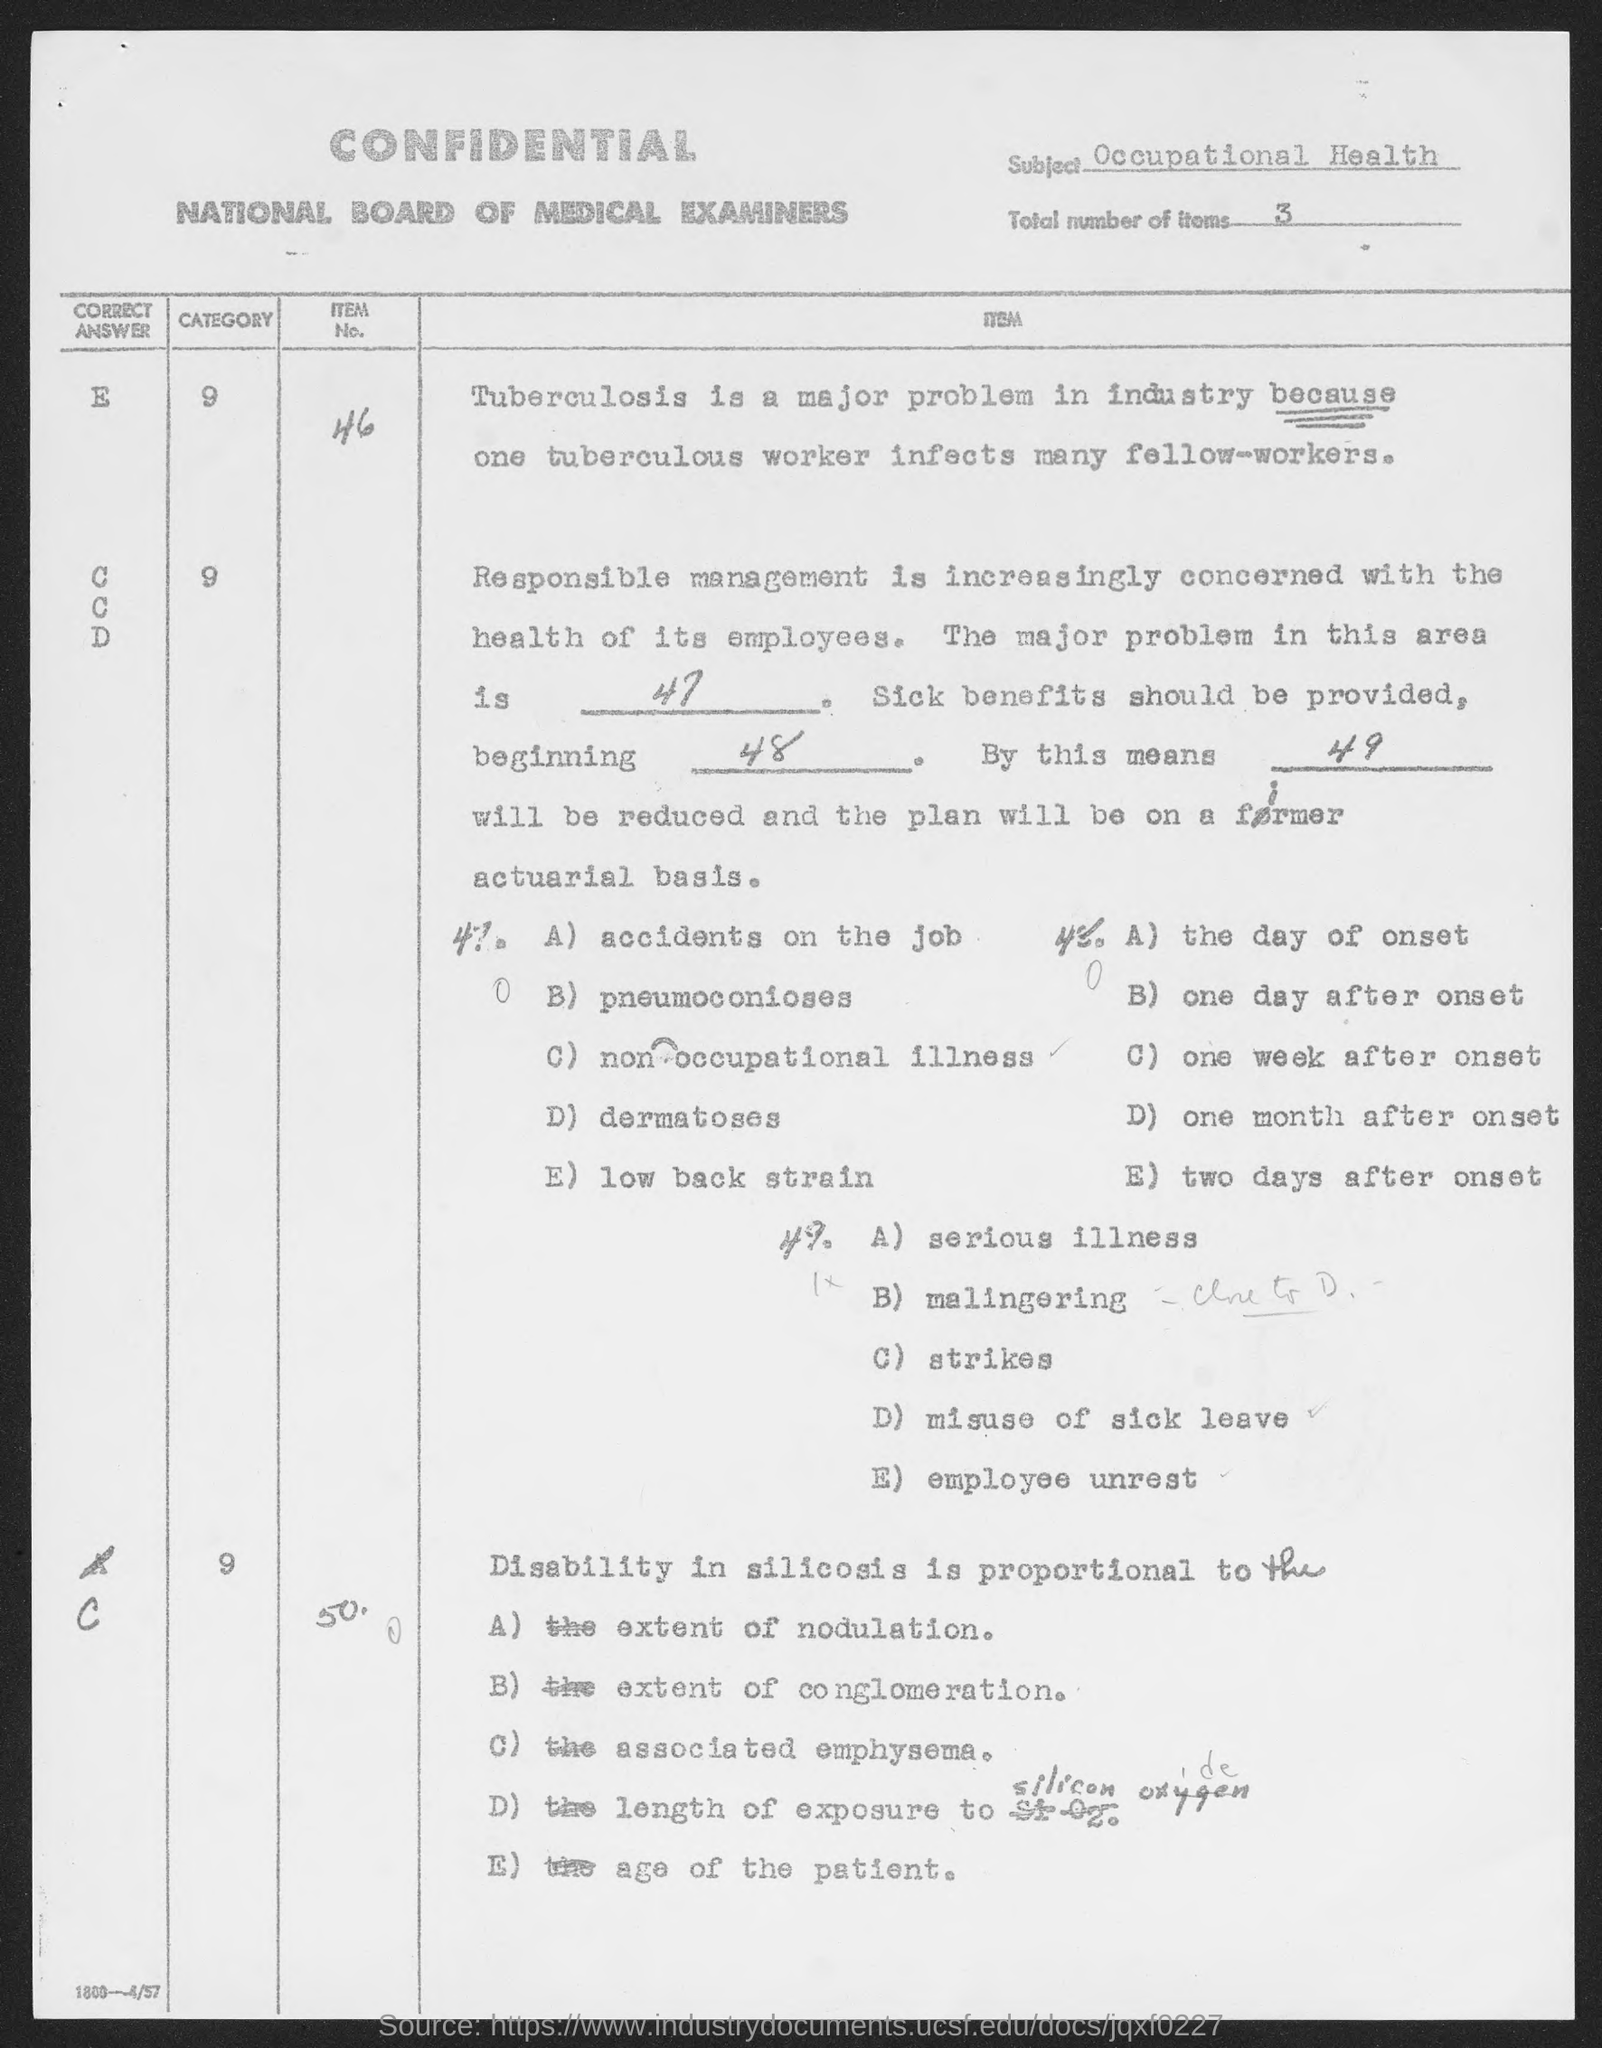What is the subject mentioned in the given page ?
Give a very brief answer. Occupational Health. What is the total number of items mentioned in the given page ?
Offer a very short reply. 3. 